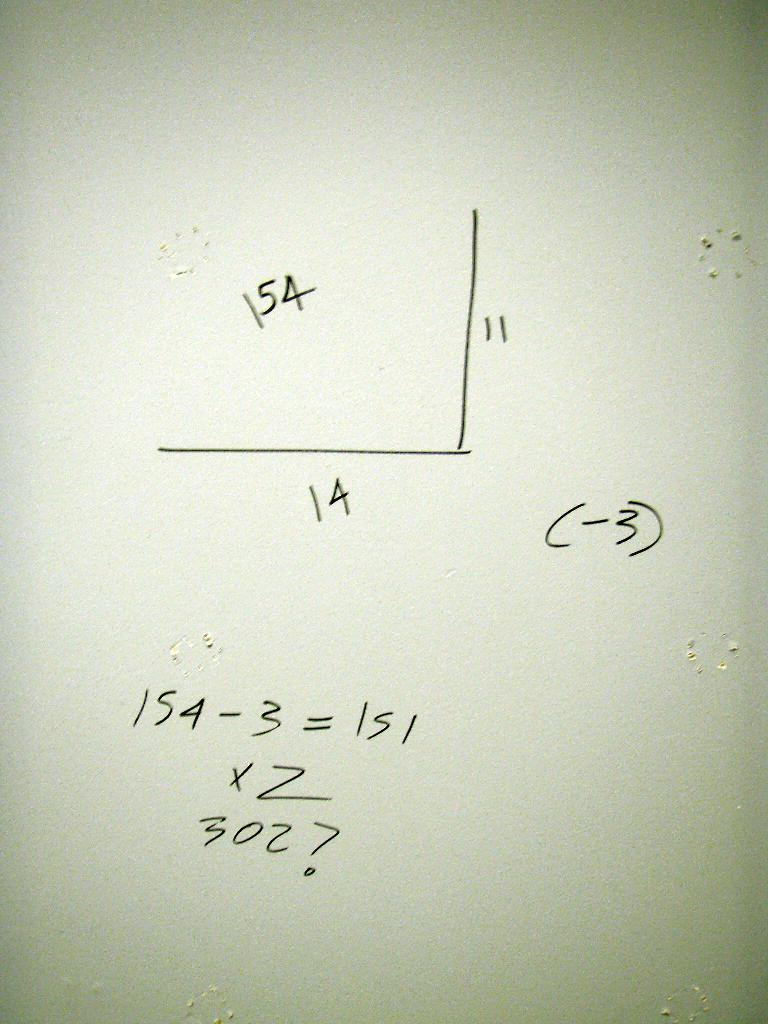What type of symbols can be seen in the image? There are numbers in the image. What else is present in the image besides numbers? There are lines in the image. Is there a woman holding a dime in her pocket in the image? There is no woman, dime, or pocket present in the image. 